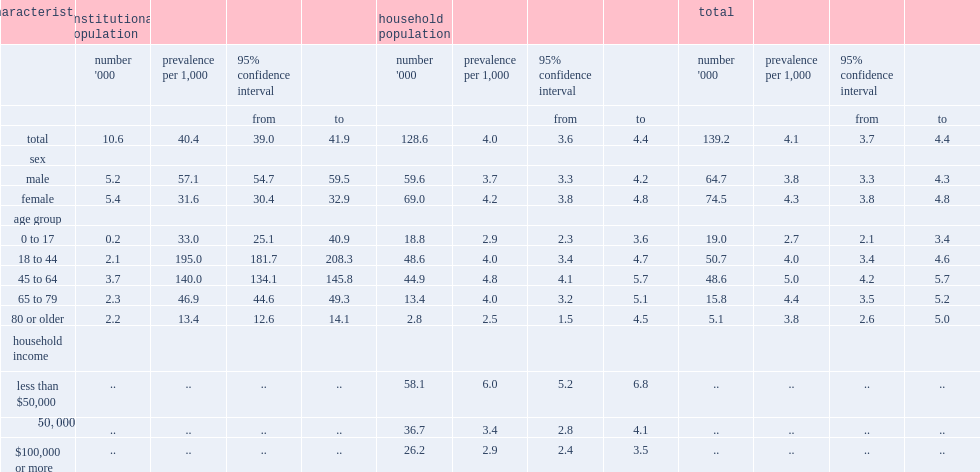How many canadians had epilepsy by estimation? 139.2. How many canadians with are in long-term care facilities? 10.6. How many canadians with are in private households? 128.6. How much was the overall prevalence of epilepsy per 1,000 among people in long-term care facilities? 40.4. Among people in long-term care facilities, which sex is more likely to have epilepsy by prevalence per 1,000? Male. In the household population, between children and youth and 18- to 44-year-olds, which were less likely to have epilepsy? 0 to 17. 